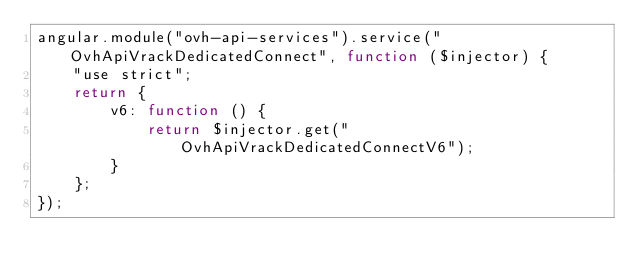Convert code to text. <code><loc_0><loc_0><loc_500><loc_500><_JavaScript_>angular.module("ovh-api-services").service("OvhApiVrackDedicatedConnect", function ($injector) {
    "use strict";
    return {
        v6: function () {
            return $injector.get("OvhApiVrackDedicatedConnectV6");
        }
    };
});
</code> 